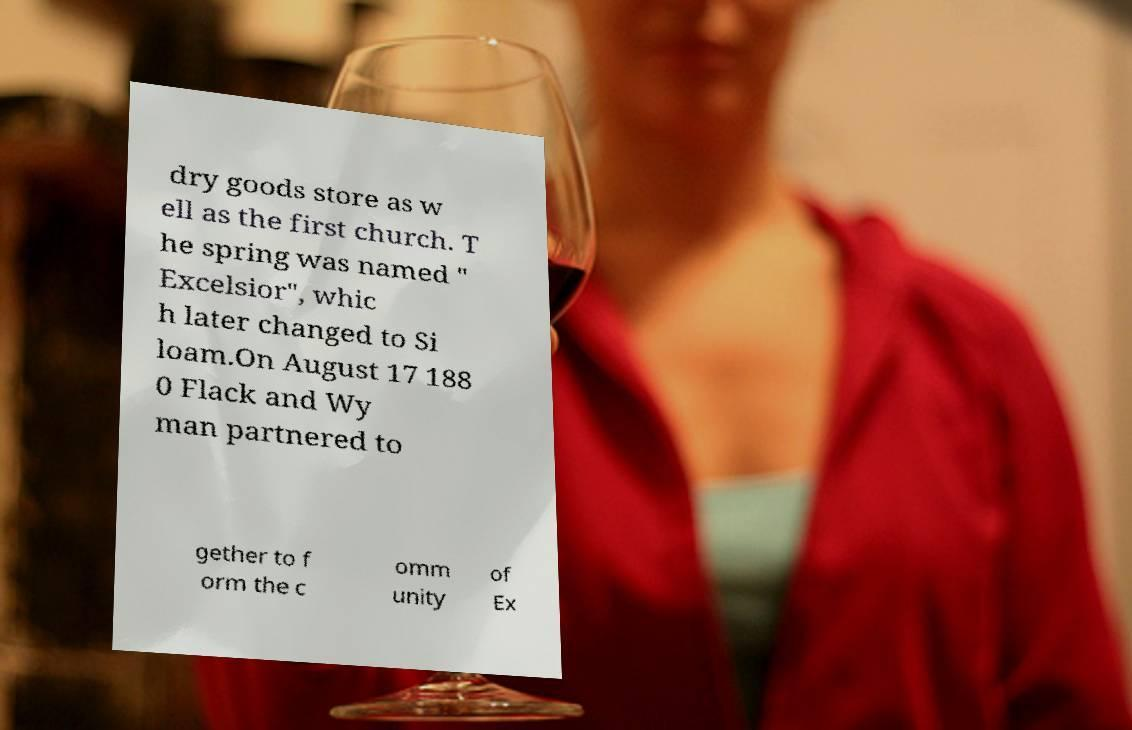I need the written content from this picture converted into text. Can you do that? dry goods store as w ell as the first church. T he spring was named " Excelsior", whic h later changed to Si loam.On August 17 188 0 Flack and Wy man partnered to gether to f orm the c omm unity of Ex 